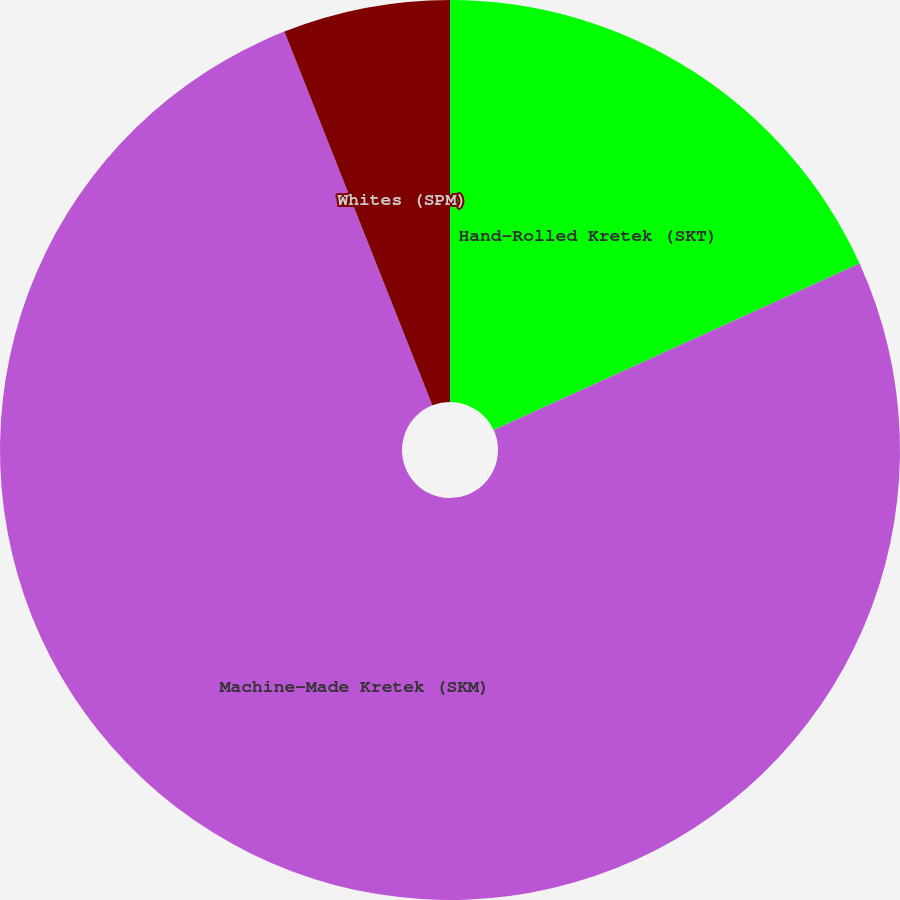Convert chart. <chart><loc_0><loc_0><loc_500><loc_500><pie_chart><fcel>Hand-Rolled Kretek (SKT)<fcel>Machine-Made Kretek (SKM)<fcel>Whites (SPM)<nl><fcel>18.2%<fcel>75.8%<fcel>6.0%<nl></chart> 